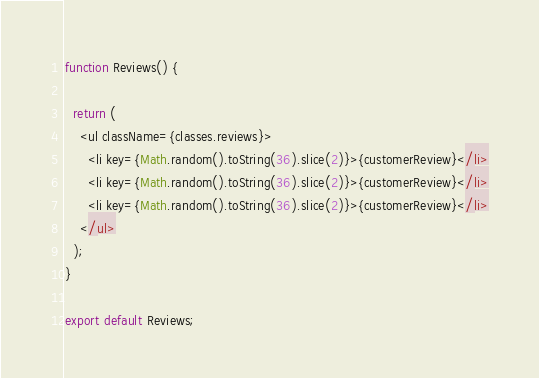<code> <loc_0><loc_0><loc_500><loc_500><_JavaScript_>
function Reviews() {

  return (
    <ul className={classes.reviews}>
      <li key={Math.random().toString(36).slice(2)}>{customerReview}</li>
      <li key={Math.random().toString(36).slice(2)}>{customerReview}</li>
      <li key={Math.random().toString(36).slice(2)}>{customerReview}</li>
    </ul>
  );
}

export default Reviews;</code> 